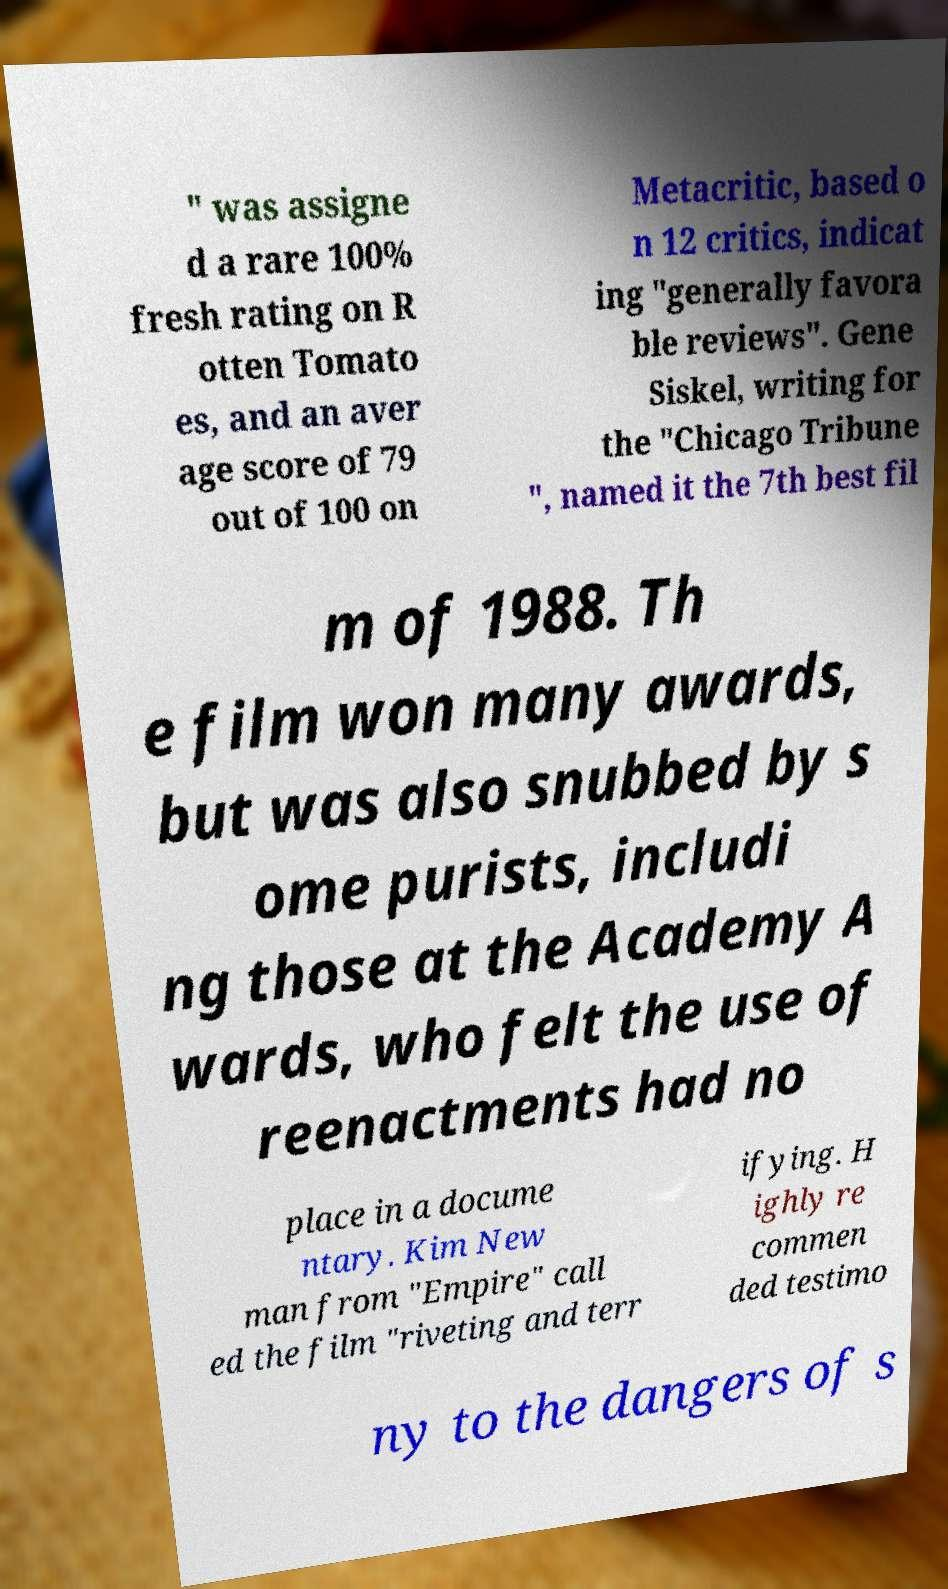I need the written content from this picture converted into text. Can you do that? " was assigne d a rare 100% fresh rating on R otten Tomato es, and an aver age score of 79 out of 100 on Metacritic, based o n 12 critics, indicat ing "generally favora ble reviews". Gene Siskel, writing for the "Chicago Tribune ", named it the 7th best fil m of 1988. Th e film won many awards, but was also snubbed by s ome purists, includi ng those at the Academy A wards, who felt the use of reenactments had no place in a docume ntary. Kim New man from "Empire" call ed the film "riveting and terr ifying. H ighly re commen ded testimo ny to the dangers of s 